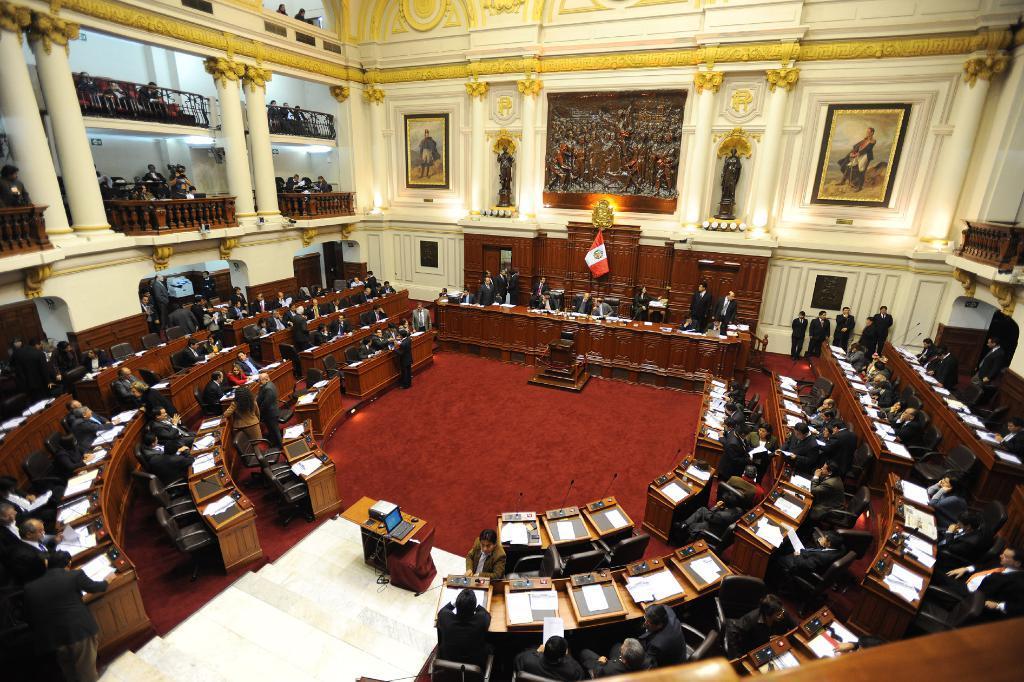Could you give a brief overview of what you see in this image? The image looks like an assembly there are lot of people sitting around the room, in the center of the room there is a table and some other people are sitting in front of the table there is a flag behind them ,in the background there is a big photo frame and also some sculptures on the wall color is gold and white. 